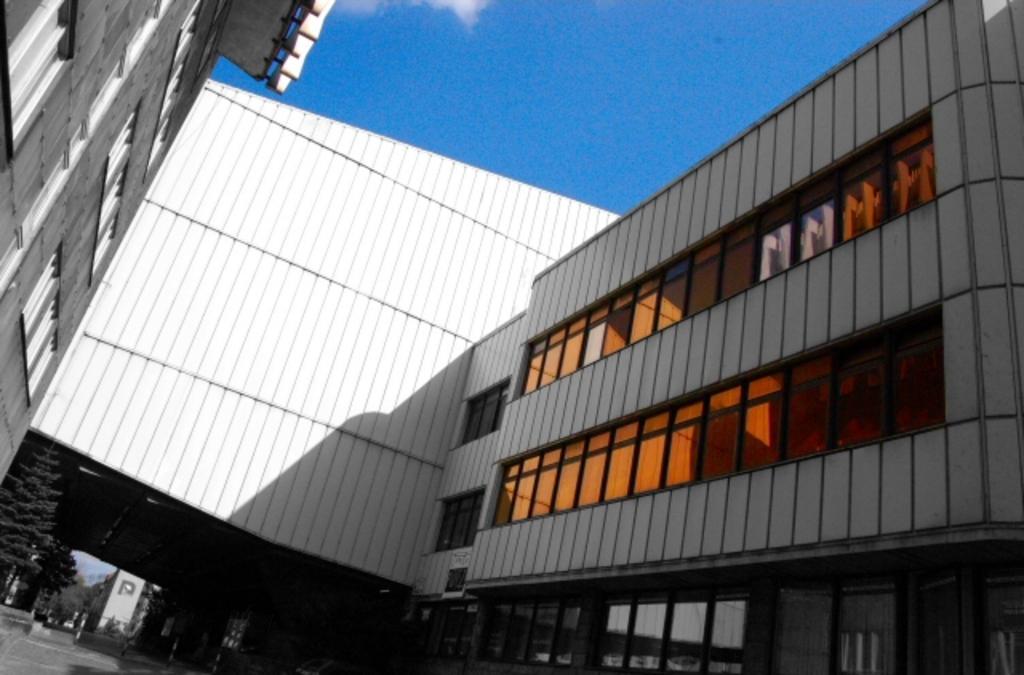Can you describe this image briefly? In this image I can see buildings. There are trees, glass windows and doors. Also there is sky. 